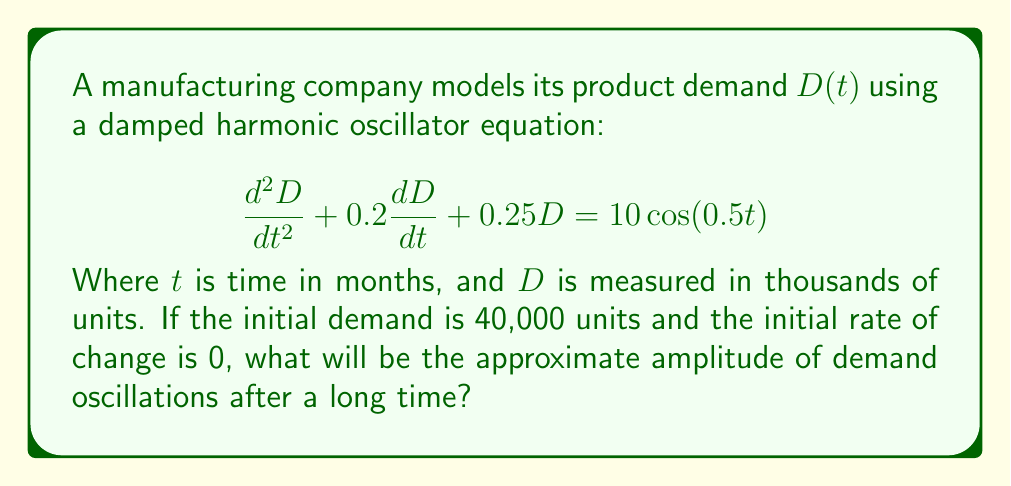Help me with this question. To solve this problem, we'll follow these steps:

1) The given equation is a forced damped harmonic oscillator. The right-hand side $10\cos(0.5t)$ represents the forcing term, which will determine the long-term behavior.

2) For a damped forced oscillator, after initial transients die out, the system will oscillate at the frequency of the forcing term.

3) The amplitude of these long-term oscillations can be found using the formula:

   $$A = \frac{F_0}{\sqrt{(k-m\omega^2)^2 + (c\omega)^2}}$$

   Where:
   $F_0$ is the amplitude of the forcing term
   $k$ is the spring constant
   $m$ is the mass
   $c$ is the damping coefficient
   $\omega$ is the angular frequency of the forcing term

4) From our equation:
   $F_0 = 10$
   $k = 0.25$
   $m = 1$ (coefficient of $\frac{d^2D}{dt^2}$)
   $c = 0.2$
   $\omega = 0.5$ (from $\cos(0.5t)$)

5) Substituting these values:

   $$A = \frac{10}{\sqrt{(0.25-1(0.5)^2)^2 + (0.2(0.5))^2}}$$

6) Simplifying:

   $$A = \frac{10}{\sqrt{0^2 + 0.1^2}} = \frac{10}{0.1} = 100$$

7) Therefore, the amplitude of the long-term oscillations will be approximately 100 thousand units.
Answer: 100,000 units 